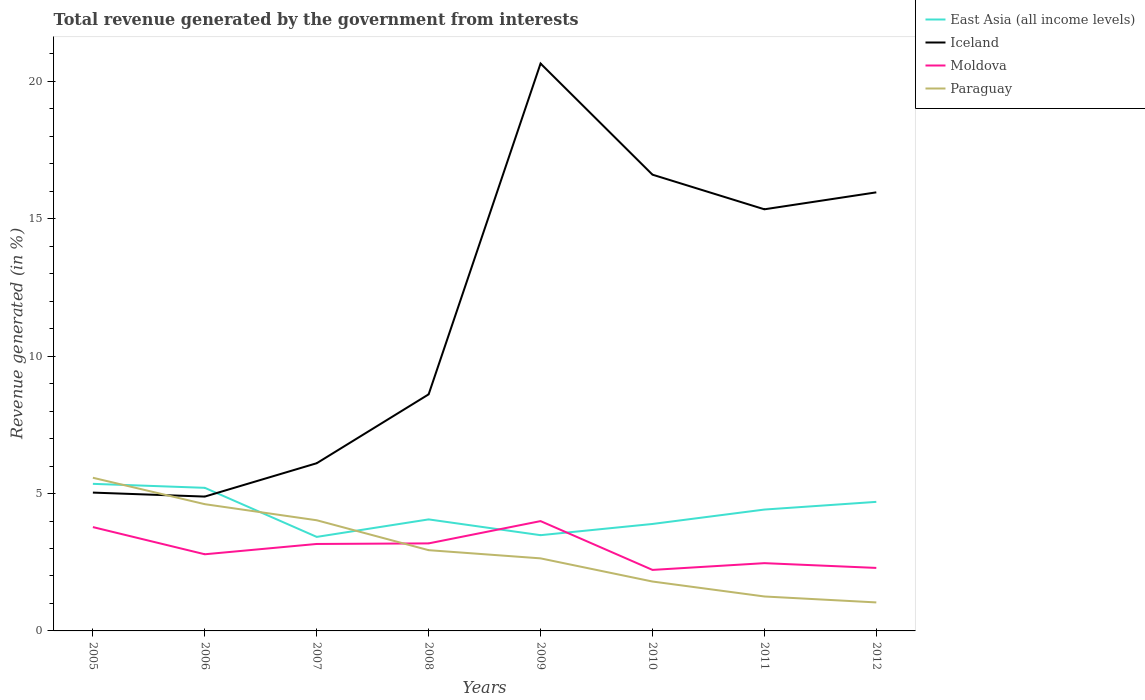How many different coloured lines are there?
Ensure brevity in your answer.  4. Across all years, what is the maximum total revenue generated in Paraguay?
Ensure brevity in your answer.  1.04. What is the total total revenue generated in Iceland in the graph?
Offer a terse response. -1.07. What is the difference between the highest and the second highest total revenue generated in East Asia (all income levels)?
Provide a short and direct response. 1.93. What is the difference between the highest and the lowest total revenue generated in Paraguay?
Give a very brief answer. 3. Is the total revenue generated in East Asia (all income levels) strictly greater than the total revenue generated in Iceland over the years?
Give a very brief answer. No. How many years are there in the graph?
Your response must be concise. 8. Are the values on the major ticks of Y-axis written in scientific E-notation?
Keep it short and to the point. No. Where does the legend appear in the graph?
Your answer should be very brief. Top right. How are the legend labels stacked?
Ensure brevity in your answer.  Vertical. What is the title of the graph?
Your answer should be compact. Total revenue generated by the government from interests. Does "Barbados" appear as one of the legend labels in the graph?
Give a very brief answer. No. What is the label or title of the Y-axis?
Offer a terse response. Revenue generated (in %). What is the Revenue generated (in %) in East Asia (all income levels) in 2005?
Offer a terse response. 5.35. What is the Revenue generated (in %) in Iceland in 2005?
Provide a succinct answer. 5.03. What is the Revenue generated (in %) of Moldova in 2005?
Your answer should be compact. 3.78. What is the Revenue generated (in %) in Paraguay in 2005?
Offer a very short reply. 5.57. What is the Revenue generated (in %) of East Asia (all income levels) in 2006?
Your response must be concise. 5.21. What is the Revenue generated (in %) of Iceland in 2006?
Offer a very short reply. 4.89. What is the Revenue generated (in %) in Moldova in 2006?
Make the answer very short. 2.79. What is the Revenue generated (in %) of Paraguay in 2006?
Your answer should be compact. 4.61. What is the Revenue generated (in %) of East Asia (all income levels) in 2007?
Keep it short and to the point. 3.42. What is the Revenue generated (in %) of Iceland in 2007?
Offer a terse response. 6.1. What is the Revenue generated (in %) in Moldova in 2007?
Offer a terse response. 3.17. What is the Revenue generated (in %) in Paraguay in 2007?
Keep it short and to the point. 4.03. What is the Revenue generated (in %) of East Asia (all income levels) in 2008?
Keep it short and to the point. 4.06. What is the Revenue generated (in %) of Iceland in 2008?
Your response must be concise. 8.61. What is the Revenue generated (in %) of Moldova in 2008?
Your answer should be compact. 3.19. What is the Revenue generated (in %) of Paraguay in 2008?
Provide a succinct answer. 2.94. What is the Revenue generated (in %) in East Asia (all income levels) in 2009?
Ensure brevity in your answer.  3.48. What is the Revenue generated (in %) of Iceland in 2009?
Give a very brief answer. 20.65. What is the Revenue generated (in %) in Moldova in 2009?
Your response must be concise. 4. What is the Revenue generated (in %) in Paraguay in 2009?
Provide a succinct answer. 2.64. What is the Revenue generated (in %) of East Asia (all income levels) in 2010?
Your answer should be very brief. 3.89. What is the Revenue generated (in %) of Iceland in 2010?
Offer a very short reply. 16.61. What is the Revenue generated (in %) of Moldova in 2010?
Keep it short and to the point. 2.22. What is the Revenue generated (in %) in Paraguay in 2010?
Ensure brevity in your answer.  1.8. What is the Revenue generated (in %) of East Asia (all income levels) in 2011?
Make the answer very short. 4.42. What is the Revenue generated (in %) in Iceland in 2011?
Ensure brevity in your answer.  15.35. What is the Revenue generated (in %) of Moldova in 2011?
Your answer should be compact. 2.47. What is the Revenue generated (in %) in Paraguay in 2011?
Give a very brief answer. 1.25. What is the Revenue generated (in %) of East Asia (all income levels) in 2012?
Keep it short and to the point. 4.7. What is the Revenue generated (in %) of Iceland in 2012?
Keep it short and to the point. 15.96. What is the Revenue generated (in %) in Moldova in 2012?
Keep it short and to the point. 2.29. What is the Revenue generated (in %) in Paraguay in 2012?
Provide a short and direct response. 1.04. Across all years, what is the maximum Revenue generated (in %) of East Asia (all income levels)?
Make the answer very short. 5.35. Across all years, what is the maximum Revenue generated (in %) in Iceland?
Your answer should be very brief. 20.65. Across all years, what is the maximum Revenue generated (in %) in Moldova?
Keep it short and to the point. 4. Across all years, what is the maximum Revenue generated (in %) in Paraguay?
Provide a succinct answer. 5.57. Across all years, what is the minimum Revenue generated (in %) of East Asia (all income levels)?
Keep it short and to the point. 3.42. Across all years, what is the minimum Revenue generated (in %) of Iceland?
Your response must be concise. 4.89. Across all years, what is the minimum Revenue generated (in %) in Moldova?
Provide a succinct answer. 2.22. Across all years, what is the minimum Revenue generated (in %) of Paraguay?
Your response must be concise. 1.04. What is the total Revenue generated (in %) of East Asia (all income levels) in the graph?
Your answer should be very brief. 34.54. What is the total Revenue generated (in %) of Iceland in the graph?
Offer a terse response. 93.21. What is the total Revenue generated (in %) in Moldova in the graph?
Keep it short and to the point. 23.9. What is the total Revenue generated (in %) of Paraguay in the graph?
Make the answer very short. 23.89. What is the difference between the Revenue generated (in %) in East Asia (all income levels) in 2005 and that in 2006?
Your answer should be very brief. 0.15. What is the difference between the Revenue generated (in %) of Iceland in 2005 and that in 2006?
Offer a terse response. 0.14. What is the difference between the Revenue generated (in %) in Paraguay in 2005 and that in 2006?
Provide a succinct answer. 0.96. What is the difference between the Revenue generated (in %) of East Asia (all income levels) in 2005 and that in 2007?
Provide a short and direct response. 1.93. What is the difference between the Revenue generated (in %) in Iceland in 2005 and that in 2007?
Offer a very short reply. -1.07. What is the difference between the Revenue generated (in %) in Moldova in 2005 and that in 2007?
Your response must be concise. 0.61. What is the difference between the Revenue generated (in %) of Paraguay in 2005 and that in 2007?
Keep it short and to the point. 1.55. What is the difference between the Revenue generated (in %) in East Asia (all income levels) in 2005 and that in 2008?
Your answer should be compact. 1.29. What is the difference between the Revenue generated (in %) in Iceland in 2005 and that in 2008?
Give a very brief answer. -3.58. What is the difference between the Revenue generated (in %) of Moldova in 2005 and that in 2008?
Give a very brief answer. 0.59. What is the difference between the Revenue generated (in %) in Paraguay in 2005 and that in 2008?
Keep it short and to the point. 2.64. What is the difference between the Revenue generated (in %) of East Asia (all income levels) in 2005 and that in 2009?
Make the answer very short. 1.87. What is the difference between the Revenue generated (in %) in Iceland in 2005 and that in 2009?
Provide a short and direct response. -15.62. What is the difference between the Revenue generated (in %) in Moldova in 2005 and that in 2009?
Make the answer very short. -0.22. What is the difference between the Revenue generated (in %) in Paraguay in 2005 and that in 2009?
Offer a terse response. 2.93. What is the difference between the Revenue generated (in %) in East Asia (all income levels) in 2005 and that in 2010?
Ensure brevity in your answer.  1.46. What is the difference between the Revenue generated (in %) of Iceland in 2005 and that in 2010?
Give a very brief answer. -11.57. What is the difference between the Revenue generated (in %) of Moldova in 2005 and that in 2010?
Offer a very short reply. 1.56. What is the difference between the Revenue generated (in %) in Paraguay in 2005 and that in 2010?
Offer a terse response. 3.78. What is the difference between the Revenue generated (in %) of East Asia (all income levels) in 2005 and that in 2011?
Provide a short and direct response. 0.94. What is the difference between the Revenue generated (in %) of Iceland in 2005 and that in 2011?
Ensure brevity in your answer.  -10.31. What is the difference between the Revenue generated (in %) in Moldova in 2005 and that in 2011?
Ensure brevity in your answer.  1.31. What is the difference between the Revenue generated (in %) in Paraguay in 2005 and that in 2011?
Give a very brief answer. 4.32. What is the difference between the Revenue generated (in %) in East Asia (all income levels) in 2005 and that in 2012?
Provide a succinct answer. 0.66. What is the difference between the Revenue generated (in %) of Iceland in 2005 and that in 2012?
Give a very brief answer. -10.93. What is the difference between the Revenue generated (in %) of Moldova in 2005 and that in 2012?
Offer a very short reply. 1.49. What is the difference between the Revenue generated (in %) in Paraguay in 2005 and that in 2012?
Provide a short and direct response. 4.54. What is the difference between the Revenue generated (in %) of East Asia (all income levels) in 2006 and that in 2007?
Your answer should be compact. 1.79. What is the difference between the Revenue generated (in %) of Iceland in 2006 and that in 2007?
Provide a short and direct response. -1.21. What is the difference between the Revenue generated (in %) in Moldova in 2006 and that in 2007?
Provide a short and direct response. -0.38. What is the difference between the Revenue generated (in %) of Paraguay in 2006 and that in 2007?
Ensure brevity in your answer.  0.59. What is the difference between the Revenue generated (in %) in East Asia (all income levels) in 2006 and that in 2008?
Offer a very short reply. 1.15. What is the difference between the Revenue generated (in %) in Iceland in 2006 and that in 2008?
Offer a terse response. -3.72. What is the difference between the Revenue generated (in %) in Moldova in 2006 and that in 2008?
Give a very brief answer. -0.4. What is the difference between the Revenue generated (in %) in Paraguay in 2006 and that in 2008?
Your answer should be compact. 1.67. What is the difference between the Revenue generated (in %) of East Asia (all income levels) in 2006 and that in 2009?
Make the answer very short. 1.72. What is the difference between the Revenue generated (in %) of Iceland in 2006 and that in 2009?
Ensure brevity in your answer.  -15.76. What is the difference between the Revenue generated (in %) in Moldova in 2006 and that in 2009?
Give a very brief answer. -1.21. What is the difference between the Revenue generated (in %) of Paraguay in 2006 and that in 2009?
Your response must be concise. 1.97. What is the difference between the Revenue generated (in %) of East Asia (all income levels) in 2006 and that in 2010?
Provide a short and direct response. 1.32. What is the difference between the Revenue generated (in %) of Iceland in 2006 and that in 2010?
Provide a short and direct response. -11.72. What is the difference between the Revenue generated (in %) of Moldova in 2006 and that in 2010?
Keep it short and to the point. 0.57. What is the difference between the Revenue generated (in %) of Paraguay in 2006 and that in 2010?
Your response must be concise. 2.82. What is the difference between the Revenue generated (in %) of East Asia (all income levels) in 2006 and that in 2011?
Ensure brevity in your answer.  0.79. What is the difference between the Revenue generated (in %) of Iceland in 2006 and that in 2011?
Provide a short and direct response. -10.46. What is the difference between the Revenue generated (in %) in Moldova in 2006 and that in 2011?
Provide a succinct answer. 0.32. What is the difference between the Revenue generated (in %) in Paraguay in 2006 and that in 2011?
Provide a succinct answer. 3.36. What is the difference between the Revenue generated (in %) in East Asia (all income levels) in 2006 and that in 2012?
Offer a terse response. 0.51. What is the difference between the Revenue generated (in %) in Iceland in 2006 and that in 2012?
Give a very brief answer. -11.07. What is the difference between the Revenue generated (in %) in Moldova in 2006 and that in 2012?
Offer a very short reply. 0.5. What is the difference between the Revenue generated (in %) in Paraguay in 2006 and that in 2012?
Offer a very short reply. 3.58. What is the difference between the Revenue generated (in %) of East Asia (all income levels) in 2007 and that in 2008?
Provide a succinct answer. -0.64. What is the difference between the Revenue generated (in %) of Iceland in 2007 and that in 2008?
Offer a terse response. -2.51. What is the difference between the Revenue generated (in %) in Moldova in 2007 and that in 2008?
Provide a short and direct response. -0.02. What is the difference between the Revenue generated (in %) in Paraguay in 2007 and that in 2008?
Offer a very short reply. 1.09. What is the difference between the Revenue generated (in %) of East Asia (all income levels) in 2007 and that in 2009?
Provide a short and direct response. -0.06. What is the difference between the Revenue generated (in %) in Iceland in 2007 and that in 2009?
Your answer should be very brief. -14.55. What is the difference between the Revenue generated (in %) of Moldova in 2007 and that in 2009?
Your response must be concise. -0.83. What is the difference between the Revenue generated (in %) in Paraguay in 2007 and that in 2009?
Offer a terse response. 1.39. What is the difference between the Revenue generated (in %) of East Asia (all income levels) in 2007 and that in 2010?
Offer a very short reply. -0.47. What is the difference between the Revenue generated (in %) of Iceland in 2007 and that in 2010?
Your answer should be very brief. -10.5. What is the difference between the Revenue generated (in %) in Moldova in 2007 and that in 2010?
Keep it short and to the point. 0.94. What is the difference between the Revenue generated (in %) of Paraguay in 2007 and that in 2010?
Give a very brief answer. 2.23. What is the difference between the Revenue generated (in %) in East Asia (all income levels) in 2007 and that in 2011?
Keep it short and to the point. -1. What is the difference between the Revenue generated (in %) in Iceland in 2007 and that in 2011?
Your answer should be very brief. -9.24. What is the difference between the Revenue generated (in %) in Moldova in 2007 and that in 2011?
Your response must be concise. 0.7. What is the difference between the Revenue generated (in %) of Paraguay in 2007 and that in 2011?
Keep it short and to the point. 2.77. What is the difference between the Revenue generated (in %) of East Asia (all income levels) in 2007 and that in 2012?
Your response must be concise. -1.28. What is the difference between the Revenue generated (in %) of Iceland in 2007 and that in 2012?
Make the answer very short. -9.86. What is the difference between the Revenue generated (in %) of Moldova in 2007 and that in 2012?
Your response must be concise. 0.87. What is the difference between the Revenue generated (in %) in Paraguay in 2007 and that in 2012?
Your response must be concise. 2.99. What is the difference between the Revenue generated (in %) in East Asia (all income levels) in 2008 and that in 2009?
Your answer should be compact. 0.57. What is the difference between the Revenue generated (in %) of Iceland in 2008 and that in 2009?
Offer a very short reply. -12.04. What is the difference between the Revenue generated (in %) of Moldova in 2008 and that in 2009?
Provide a short and direct response. -0.81. What is the difference between the Revenue generated (in %) of Paraguay in 2008 and that in 2009?
Make the answer very short. 0.3. What is the difference between the Revenue generated (in %) in East Asia (all income levels) in 2008 and that in 2010?
Offer a terse response. 0.17. What is the difference between the Revenue generated (in %) in Iceland in 2008 and that in 2010?
Ensure brevity in your answer.  -8. What is the difference between the Revenue generated (in %) in Moldova in 2008 and that in 2010?
Offer a terse response. 0.96. What is the difference between the Revenue generated (in %) in Paraguay in 2008 and that in 2010?
Offer a terse response. 1.14. What is the difference between the Revenue generated (in %) of East Asia (all income levels) in 2008 and that in 2011?
Make the answer very short. -0.36. What is the difference between the Revenue generated (in %) in Iceland in 2008 and that in 2011?
Ensure brevity in your answer.  -6.74. What is the difference between the Revenue generated (in %) in Moldova in 2008 and that in 2011?
Offer a very short reply. 0.72. What is the difference between the Revenue generated (in %) in Paraguay in 2008 and that in 2011?
Offer a very short reply. 1.69. What is the difference between the Revenue generated (in %) in East Asia (all income levels) in 2008 and that in 2012?
Offer a terse response. -0.64. What is the difference between the Revenue generated (in %) of Iceland in 2008 and that in 2012?
Make the answer very short. -7.35. What is the difference between the Revenue generated (in %) in Moldova in 2008 and that in 2012?
Offer a very short reply. 0.89. What is the difference between the Revenue generated (in %) of Paraguay in 2008 and that in 2012?
Give a very brief answer. 1.9. What is the difference between the Revenue generated (in %) of East Asia (all income levels) in 2009 and that in 2010?
Your answer should be very brief. -0.41. What is the difference between the Revenue generated (in %) in Iceland in 2009 and that in 2010?
Your response must be concise. 4.05. What is the difference between the Revenue generated (in %) of Moldova in 2009 and that in 2010?
Provide a succinct answer. 1.78. What is the difference between the Revenue generated (in %) in Paraguay in 2009 and that in 2010?
Ensure brevity in your answer.  0.84. What is the difference between the Revenue generated (in %) of East Asia (all income levels) in 2009 and that in 2011?
Give a very brief answer. -0.93. What is the difference between the Revenue generated (in %) in Iceland in 2009 and that in 2011?
Your answer should be compact. 5.31. What is the difference between the Revenue generated (in %) in Moldova in 2009 and that in 2011?
Give a very brief answer. 1.53. What is the difference between the Revenue generated (in %) in Paraguay in 2009 and that in 2011?
Keep it short and to the point. 1.39. What is the difference between the Revenue generated (in %) in East Asia (all income levels) in 2009 and that in 2012?
Your answer should be very brief. -1.21. What is the difference between the Revenue generated (in %) in Iceland in 2009 and that in 2012?
Your response must be concise. 4.69. What is the difference between the Revenue generated (in %) in Moldova in 2009 and that in 2012?
Ensure brevity in your answer.  1.7. What is the difference between the Revenue generated (in %) in Paraguay in 2009 and that in 2012?
Keep it short and to the point. 1.6. What is the difference between the Revenue generated (in %) of East Asia (all income levels) in 2010 and that in 2011?
Provide a succinct answer. -0.52. What is the difference between the Revenue generated (in %) in Iceland in 2010 and that in 2011?
Your response must be concise. 1.26. What is the difference between the Revenue generated (in %) of Moldova in 2010 and that in 2011?
Your response must be concise. -0.25. What is the difference between the Revenue generated (in %) in Paraguay in 2010 and that in 2011?
Offer a very short reply. 0.54. What is the difference between the Revenue generated (in %) in East Asia (all income levels) in 2010 and that in 2012?
Provide a succinct answer. -0.8. What is the difference between the Revenue generated (in %) of Iceland in 2010 and that in 2012?
Give a very brief answer. 0.64. What is the difference between the Revenue generated (in %) of Moldova in 2010 and that in 2012?
Your answer should be compact. -0.07. What is the difference between the Revenue generated (in %) of Paraguay in 2010 and that in 2012?
Offer a very short reply. 0.76. What is the difference between the Revenue generated (in %) of East Asia (all income levels) in 2011 and that in 2012?
Provide a succinct answer. -0.28. What is the difference between the Revenue generated (in %) of Iceland in 2011 and that in 2012?
Your answer should be compact. -0.62. What is the difference between the Revenue generated (in %) of Moldova in 2011 and that in 2012?
Keep it short and to the point. 0.17. What is the difference between the Revenue generated (in %) in Paraguay in 2011 and that in 2012?
Your answer should be compact. 0.22. What is the difference between the Revenue generated (in %) of East Asia (all income levels) in 2005 and the Revenue generated (in %) of Iceland in 2006?
Your answer should be compact. 0.46. What is the difference between the Revenue generated (in %) in East Asia (all income levels) in 2005 and the Revenue generated (in %) in Moldova in 2006?
Offer a terse response. 2.56. What is the difference between the Revenue generated (in %) of East Asia (all income levels) in 2005 and the Revenue generated (in %) of Paraguay in 2006?
Offer a terse response. 0.74. What is the difference between the Revenue generated (in %) in Iceland in 2005 and the Revenue generated (in %) in Moldova in 2006?
Provide a short and direct response. 2.24. What is the difference between the Revenue generated (in %) of Iceland in 2005 and the Revenue generated (in %) of Paraguay in 2006?
Give a very brief answer. 0.42. What is the difference between the Revenue generated (in %) in Moldova in 2005 and the Revenue generated (in %) in Paraguay in 2006?
Make the answer very short. -0.83. What is the difference between the Revenue generated (in %) in East Asia (all income levels) in 2005 and the Revenue generated (in %) in Iceland in 2007?
Your answer should be very brief. -0.75. What is the difference between the Revenue generated (in %) in East Asia (all income levels) in 2005 and the Revenue generated (in %) in Moldova in 2007?
Your answer should be compact. 2.19. What is the difference between the Revenue generated (in %) of East Asia (all income levels) in 2005 and the Revenue generated (in %) of Paraguay in 2007?
Ensure brevity in your answer.  1.33. What is the difference between the Revenue generated (in %) in Iceland in 2005 and the Revenue generated (in %) in Moldova in 2007?
Your answer should be compact. 1.87. What is the difference between the Revenue generated (in %) of Iceland in 2005 and the Revenue generated (in %) of Paraguay in 2007?
Your response must be concise. 1.01. What is the difference between the Revenue generated (in %) in Moldova in 2005 and the Revenue generated (in %) in Paraguay in 2007?
Offer a very short reply. -0.25. What is the difference between the Revenue generated (in %) of East Asia (all income levels) in 2005 and the Revenue generated (in %) of Iceland in 2008?
Your answer should be very brief. -3.26. What is the difference between the Revenue generated (in %) of East Asia (all income levels) in 2005 and the Revenue generated (in %) of Moldova in 2008?
Provide a succinct answer. 2.17. What is the difference between the Revenue generated (in %) of East Asia (all income levels) in 2005 and the Revenue generated (in %) of Paraguay in 2008?
Give a very brief answer. 2.41. What is the difference between the Revenue generated (in %) of Iceland in 2005 and the Revenue generated (in %) of Moldova in 2008?
Your response must be concise. 1.85. What is the difference between the Revenue generated (in %) of Iceland in 2005 and the Revenue generated (in %) of Paraguay in 2008?
Ensure brevity in your answer.  2.1. What is the difference between the Revenue generated (in %) in Moldova in 2005 and the Revenue generated (in %) in Paraguay in 2008?
Provide a short and direct response. 0.84. What is the difference between the Revenue generated (in %) of East Asia (all income levels) in 2005 and the Revenue generated (in %) of Iceland in 2009?
Ensure brevity in your answer.  -15.3. What is the difference between the Revenue generated (in %) of East Asia (all income levels) in 2005 and the Revenue generated (in %) of Moldova in 2009?
Your answer should be compact. 1.36. What is the difference between the Revenue generated (in %) in East Asia (all income levels) in 2005 and the Revenue generated (in %) in Paraguay in 2009?
Keep it short and to the point. 2.71. What is the difference between the Revenue generated (in %) of Iceland in 2005 and the Revenue generated (in %) of Moldova in 2009?
Your answer should be very brief. 1.04. What is the difference between the Revenue generated (in %) of Iceland in 2005 and the Revenue generated (in %) of Paraguay in 2009?
Your answer should be very brief. 2.39. What is the difference between the Revenue generated (in %) in Moldova in 2005 and the Revenue generated (in %) in Paraguay in 2009?
Provide a short and direct response. 1.14. What is the difference between the Revenue generated (in %) in East Asia (all income levels) in 2005 and the Revenue generated (in %) in Iceland in 2010?
Make the answer very short. -11.25. What is the difference between the Revenue generated (in %) of East Asia (all income levels) in 2005 and the Revenue generated (in %) of Moldova in 2010?
Ensure brevity in your answer.  3.13. What is the difference between the Revenue generated (in %) in East Asia (all income levels) in 2005 and the Revenue generated (in %) in Paraguay in 2010?
Provide a succinct answer. 3.56. What is the difference between the Revenue generated (in %) of Iceland in 2005 and the Revenue generated (in %) of Moldova in 2010?
Keep it short and to the point. 2.81. What is the difference between the Revenue generated (in %) in Iceland in 2005 and the Revenue generated (in %) in Paraguay in 2010?
Offer a terse response. 3.24. What is the difference between the Revenue generated (in %) in Moldova in 2005 and the Revenue generated (in %) in Paraguay in 2010?
Provide a succinct answer. 1.98. What is the difference between the Revenue generated (in %) of East Asia (all income levels) in 2005 and the Revenue generated (in %) of Iceland in 2011?
Provide a short and direct response. -9.99. What is the difference between the Revenue generated (in %) in East Asia (all income levels) in 2005 and the Revenue generated (in %) in Moldova in 2011?
Ensure brevity in your answer.  2.89. What is the difference between the Revenue generated (in %) in East Asia (all income levels) in 2005 and the Revenue generated (in %) in Paraguay in 2011?
Offer a very short reply. 4.1. What is the difference between the Revenue generated (in %) in Iceland in 2005 and the Revenue generated (in %) in Moldova in 2011?
Your answer should be compact. 2.57. What is the difference between the Revenue generated (in %) in Iceland in 2005 and the Revenue generated (in %) in Paraguay in 2011?
Ensure brevity in your answer.  3.78. What is the difference between the Revenue generated (in %) of Moldova in 2005 and the Revenue generated (in %) of Paraguay in 2011?
Offer a very short reply. 2.53. What is the difference between the Revenue generated (in %) of East Asia (all income levels) in 2005 and the Revenue generated (in %) of Iceland in 2012?
Offer a very short reply. -10.61. What is the difference between the Revenue generated (in %) in East Asia (all income levels) in 2005 and the Revenue generated (in %) in Moldova in 2012?
Your answer should be compact. 3.06. What is the difference between the Revenue generated (in %) of East Asia (all income levels) in 2005 and the Revenue generated (in %) of Paraguay in 2012?
Your answer should be very brief. 4.32. What is the difference between the Revenue generated (in %) in Iceland in 2005 and the Revenue generated (in %) in Moldova in 2012?
Your answer should be compact. 2.74. What is the difference between the Revenue generated (in %) of Iceland in 2005 and the Revenue generated (in %) of Paraguay in 2012?
Ensure brevity in your answer.  4. What is the difference between the Revenue generated (in %) of Moldova in 2005 and the Revenue generated (in %) of Paraguay in 2012?
Provide a succinct answer. 2.74. What is the difference between the Revenue generated (in %) in East Asia (all income levels) in 2006 and the Revenue generated (in %) in Iceland in 2007?
Ensure brevity in your answer.  -0.9. What is the difference between the Revenue generated (in %) in East Asia (all income levels) in 2006 and the Revenue generated (in %) in Moldova in 2007?
Offer a very short reply. 2.04. What is the difference between the Revenue generated (in %) of East Asia (all income levels) in 2006 and the Revenue generated (in %) of Paraguay in 2007?
Your response must be concise. 1.18. What is the difference between the Revenue generated (in %) of Iceland in 2006 and the Revenue generated (in %) of Moldova in 2007?
Give a very brief answer. 1.72. What is the difference between the Revenue generated (in %) of Iceland in 2006 and the Revenue generated (in %) of Paraguay in 2007?
Provide a short and direct response. 0.86. What is the difference between the Revenue generated (in %) in Moldova in 2006 and the Revenue generated (in %) in Paraguay in 2007?
Offer a very short reply. -1.24. What is the difference between the Revenue generated (in %) in East Asia (all income levels) in 2006 and the Revenue generated (in %) in Iceland in 2008?
Ensure brevity in your answer.  -3.4. What is the difference between the Revenue generated (in %) in East Asia (all income levels) in 2006 and the Revenue generated (in %) in Moldova in 2008?
Your response must be concise. 2.02. What is the difference between the Revenue generated (in %) in East Asia (all income levels) in 2006 and the Revenue generated (in %) in Paraguay in 2008?
Your answer should be very brief. 2.27. What is the difference between the Revenue generated (in %) of Iceland in 2006 and the Revenue generated (in %) of Moldova in 2008?
Your answer should be compact. 1.7. What is the difference between the Revenue generated (in %) in Iceland in 2006 and the Revenue generated (in %) in Paraguay in 2008?
Your response must be concise. 1.95. What is the difference between the Revenue generated (in %) of Moldova in 2006 and the Revenue generated (in %) of Paraguay in 2008?
Ensure brevity in your answer.  -0.15. What is the difference between the Revenue generated (in %) of East Asia (all income levels) in 2006 and the Revenue generated (in %) of Iceland in 2009?
Provide a succinct answer. -15.44. What is the difference between the Revenue generated (in %) in East Asia (all income levels) in 2006 and the Revenue generated (in %) in Moldova in 2009?
Provide a succinct answer. 1.21. What is the difference between the Revenue generated (in %) in East Asia (all income levels) in 2006 and the Revenue generated (in %) in Paraguay in 2009?
Offer a terse response. 2.57. What is the difference between the Revenue generated (in %) in Iceland in 2006 and the Revenue generated (in %) in Moldova in 2009?
Give a very brief answer. 0.89. What is the difference between the Revenue generated (in %) in Iceland in 2006 and the Revenue generated (in %) in Paraguay in 2009?
Your answer should be compact. 2.25. What is the difference between the Revenue generated (in %) of Moldova in 2006 and the Revenue generated (in %) of Paraguay in 2009?
Your answer should be very brief. 0.15. What is the difference between the Revenue generated (in %) in East Asia (all income levels) in 2006 and the Revenue generated (in %) in Iceland in 2010?
Your answer should be compact. -11.4. What is the difference between the Revenue generated (in %) in East Asia (all income levels) in 2006 and the Revenue generated (in %) in Moldova in 2010?
Make the answer very short. 2.99. What is the difference between the Revenue generated (in %) of East Asia (all income levels) in 2006 and the Revenue generated (in %) of Paraguay in 2010?
Provide a succinct answer. 3.41. What is the difference between the Revenue generated (in %) in Iceland in 2006 and the Revenue generated (in %) in Moldova in 2010?
Give a very brief answer. 2.67. What is the difference between the Revenue generated (in %) of Iceland in 2006 and the Revenue generated (in %) of Paraguay in 2010?
Keep it short and to the point. 3.09. What is the difference between the Revenue generated (in %) of East Asia (all income levels) in 2006 and the Revenue generated (in %) of Iceland in 2011?
Provide a succinct answer. -10.14. What is the difference between the Revenue generated (in %) in East Asia (all income levels) in 2006 and the Revenue generated (in %) in Moldova in 2011?
Provide a short and direct response. 2.74. What is the difference between the Revenue generated (in %) in East Asia (all income levels) in 2006 and the Revenue generated (in %) in Paraguay in 2011?
Offer a terse response. 3.96. What is the difference between the Revenue generated (in %) of Iceland in 2006 and the Revenue generated (in %) of Moldova in 2011?
Your answer should be very brief. 2.42. What is the difference between the Revenue generated (in %) of Iceland in 2006 and the Revenue generated (in %) of Paraguay in 2011?
Offer a terse response. 3.64. What is the difference between the Revenue generated (in %) in Moldova in 2006 and the Revenue generated (in %) in Paraguay in 2011?
Ensure brevity in your answer.  1.54. What is the difference between the Revenue generated (in %) in East Asia (all income levels) in 2006 and the Revenue generated (in %) in Iceland in 2012?
Offer a very short reply. -10.76. What is the difference between the Revenue generated (in %) of East Asia (all income levels) in 2006 and the Revenue generated (in %) of Moldova in 2012?
Give a very brief answer. 2.92. What is the difference between the Revenue generated (in %) in East Asia (all income levels) in 2006 and the Revenue generated (in %) in Paraguay in 2012?
Provide a short and direct response. 4.17. What is the difference between the Revenue generated (in %) of Iceland in 2006 and the Revenue generated (in %) of Moldova in 2012?
Keep it short and to the point. 2.6. What is the difference between the Revenue generated (in %) in Iceland in 2006 and the Revenue generated (in %) in Paraguay in 2012?
Ensure brevity in your answer.  3.85. What is the difference between the Revenue generated (in %) of Moldova in 2006 and the Revenue generated (in %) of Paraguay in 2012?
Give a very brief answer. 1.75. What is the difference between the Revenue generated (in %) of East Asia (all income levels) in 2007 and the Revenue generated (in %) of Iceland in 2008?
Ensure brevity in your answer.  -5.19. What is the difference between the Revenue generated (in %) in East Asia (all income levels) in 2007 and the Revenue generated (in %) in Moldova in 2008?
Ensure brevity in your answer.  0.24. What is the difference between the Revenue generated (in %) in East Asia (all income levels) in 2007 and the Revenue generated (in %) in Paraguay in 2008?
Provide a short and direct response. 0.48. What is the difference between the Revenue generated (in %) of Iceland in 2007 and the Revenue generated (in %) of Moldova in 2008?
Provide a short and direct response. 2.92. What is the difference between the Revenue generated (in %) of Iceland in 2007 and the Revenue generated (in %) of Paraguay in 2008?
Provide a short and direct response. 3.17. What is the difference between the Revenue generated (in %) in Moldova in 2007 and the Revenue generated (in %) in Paraguay in 2008?
Make the answer very short. 0.23. What is the difference between the Revenue generated (in %) of East Asia (all income levels) in 2007 and the Revenue generated (in %) of Iceland in 2009?
Your response must be concise. -17.23. What is the difference between the Revenue generated (in %) of East Asia (all income levels) in 2007 and the Revenue generated (in %) of Moldova in 2009?
Your response must be concise. -0.57. What is the difference between the Revenue generated (in %) in East Asia (all income levels) in 2007 and the Revenue generated (in %) in Paraguay in 2009?
Provide a short and direct response. 0.78. What is the difference between the Revenue generated (in %) of Iceland in 2007 and the Revenue generated (in %) of Moldova in 2009?
Provide a short and direct response. 2.11. What is the difference between the Revenue generated (in %) of Iceland in 2007 and the Revenue generated (in %) of Paraguay in 2009?
Your answer should be very brief. 3.46. What is the difference between the Revenue generated (in %) in Moldova in 2007 and the Revenue generated (in %) in Paraguay in 2009?
Your answer should be very brief. 0.52. What is the difference between the Revenue generated (in %) of East Asia (all income levels) in 2007 and the Revenue generated (in %) of Iceland in 2010?
Offer a very short reply. -13.18. What is the difference between the Revenue generated (in %) in East Asia (all income levels) in 2007 and the Revenue generated (in %) in Moldova in 2010?
Your answer should be very brief. 1.2. What is the difference between the Revenue generated (in %) of East Asia (all income levels) in 2007 and the Revenue generated (in %) of Paraguay in 2010?
Keep it short and to the point. 1.62. What is the difference between the Revenue generated (in %) of Iceland in 2007 and the Revenue generated (in %) of Moldova in 2010?
Offer a very short reply. 3.88. What is the difference between the Revenue generated (in %) of Iceland in 2007 and the Revenue generated (in %) of Paraguay in 2010?
Provide a short and direct response. 4.31. What is the difference between the Revenue generated (in %) of Moldova in 2007 and the Revenue generated (in %) of Paraguay in 2010?
Offer a very short reply. 1.37. What is the difference between the Revenue generated (in %) in East Asia (all income levels) in 2007 and the Revenue generated (in %) in Iceland in 2011?
Keep it short and to the point. -11.92. What is the difference between the Revenue generated (in %) of East Asia (all income levels) in 2007 and the Revenue generated (in %) of Moldova in 2011?
Offer a very short reply. 0.96. What is the difference between the Revenue generated (in %) of East Asia (all income levels) in 2007 and the Revenue generated (in %) of Paraguay in 2011?
Your response must be concise. 2.17. What is the difference between the Revenue generated (in %) in Iceland in 2007 and the Revenue generated (in %) in Moldova in 2011?
Offer a very short reply. 3.64. What is the difference between the Revenue generated (in %) of Iceland in 2007 and the Revenue generated (in %) of Paraguay in 2011?
Your answer should be compact. 4.85. What is the difference between the Revenue generated (in %) of Moldova in 2007 and the Revenue generated (in %) of Paraguay in 2011?
Ensure brevity in your answer.  1.91. What is the difference between the Revenue generated (in %) of East Asia (all income levels) in 2007 and the Revenue generated (in %) of Iceland in 2012?
Provide a succinct answer. -12.54. What is the difference between the Revenue generated (in %) of East Asia (all income levels) in 2007 and the Revenue generated (in %) of Moldova in 2012?
Give a very brief answer. 1.13. What is the difference between the Revenue generated (in %) in East Asia (all income levels) in 2007 and the Revenue generated (in %) in Paraguay in 2012?
Offer a terse response. 2.39. What is the difference between the Revenue generated (in %) in Iceland in 2007 and the Revenue generated (in %) in Moldova in 2012?
Ensure brevity in your answer.  3.81. What is the difference between the Revenue generated (in %) of Iceland in 2007 and the Revenue generated (in %) of Paraguay in 2012?
Offer a terse response. 5.07. What is the difference between the Revenue generated (in %) in Moldova in 2007 and the Revenue generated (in %) in Paraguay in 2012?
Provide a short and direct response. 2.13. What is the difference between the Revenue generated (in %) of East Asia (all income levels) in 2008 and the Revenue generated (in %) of Iceland in 2009?
Provide a short and direct response. -16.59. What is the difference between the Revenue generated (in %) in East Asia (all income levels) in 2008 and the Revenue generated (in %) in Moldova in 2009?
Provide a short and direct response. 0.06. What is the difference between the Revenue generated (in %) in East Asia (all income levels) in 2008 and the Revenue generated (in %) in Paraguay in 2009?
Offer a very short reply. 1.42. What is the difference between the Revenue generated (in %) of Iceland in 2008 and the Revenue generated (in %) of Moldova in 2009?
Your response must be concise. 4.61. What is the difference between the Revenue generated (in %) of Iceland in 2008 and the Revenue generated (in %) of Paraguay in 2009?
Your answer should be very brief. 5.97. What is the difference between the Revenue generated (in %) in Moldova in 2008 and the Revenue generated (in %) in Paraguay in 2009?
Your answer should be compact. 0.55. What is the difference between the Revenue generated (in %) of East Asia (all income levels) in 2008 and the Revenue generated (in %) of Iceland in 2010?
Offer a very short reply. -12.55. What is the difference between the Revenue generated (in %) in East Asia (all income levels) in 2008 and the Revenue generated (in %) in Moldova in 2010?
Your response must be concise. 1.84. What is the difference between the Revenue generated (in %) of East Asia (all income levels) in 2008 and the Revenue generated (in %) of Paraguay in 2010?
Your answer should be compact. 2.26. What is the difference between the Revenue generated (in %) in Iceland in 2008 and the Revenue generated (in %) in Moldova in 2010?
Provide a short and direct response. 6.39. What is the difference between the Revenue generated (in %) of Iceland in 2008 and the Revenue generated (in %) of Paraguay in 2010?
Offer a terse response. 6.81. What is the difference between the Revenue generated (in %) of Moldova in 2008 and the Revenue generated (in %) of Paraguay in 2010?
Keep it short and to the point. 1.39. What is the difference between the Revenue generated (in %) of East Asia (all income levels) in 2008 and the Revenue generated (in %) of Iceland in 2011?
Offer a terse response. -11.29. What is the difference between the Revenue generated (in %) of East Asia (all income levels) in 2008 and the Revenue generated (in %) of Moldova in 2011?
Provide a succinct answer. 1.59. What is the difference between the Revenue generated (in %) in East Asia (all income levels) in 2008 and the Revenue generated (in %) in Paraguay in 2011?
Ensure brevity in your answer.  2.81. What is the difference between the Revenue generated (in %) in Iceland in 2008 and the Revenue generated (in %) in Moldova in 2011?
Offer a terse response. 6.14. What is the difference between the Revenue generated (in %) of Iceland in 2008 and the Revenue generated (in %) of Paraguay in 2011?
Your answer should be compact. 7.36. What is the difference between the Revenue generated (in %) in Moldova in 2008 and the Revenue generated (in %) in Paraguay in 2011?
Give a very brief answer. 1.93. What is the difference between the Revenue generated (in %) of East Asia (all income levels) in 2008 and the Revenue generated (in %) of Iceland in 2012?
Your answer should be very brief. -11.9. What is the difference between the Revenue generated (in %) in East Asia (all income levels) in 2008 and the Revenue generated (in %) in Moldova in 2012?
Provide a short and direct response. 1.77. What is the difference between the Revenue generated (in %) of East Asia (all income levels) in 2008 and the Revenue generated (in %) of Paraguay in 2012?
Ensure brevity in your answer.  3.02. What is the difference between the Revenue generated (in %) in Iceland in 2008 and the Revenue generated (in %) in Moldova in 2012?
Provide a short and direct response. 6.32. What is the difference between the Revenue generated (in %) in Iceland in 2008 and the Revenue generated (in %) in Paraguay in 2012?
Ensure brevity in your answer.  7.57. What is the difference between the Revenue generated (in %) of Moldova in 2008 and the Revenue generated (in %) of Paraguay in 2012?
Keep it short and to the point. 2.15. What is the difference between the Revenue generated (in %) of East Asia (all income levels) in 2009 and the Revenue generated (in %) of Iceland in 2010?
Offer a very short reply. -13.12. What is the difference between the Revenue generated (in %) of East Asia (all income levels) in 2009 and the Revenue generated (in %) of Moldova in 2010?
Provide a succinct answer. 1.26. What is the difference between the Revenue generated (in %) in East Asia (all income levels) in 2009 and the Revenue generated (in %) in Paraguay in 2010?
Provide a succinct answer. 1.69. What is the difference between the Revenue generated (in %) in Iceland in 2009 and the Revenue generated (in %) in Moldova in 2010?
Keep it short and to the point. 18.43. What is the difference between the Revenue generated (in %) of Iceland in 2009 and the Revenue generated (in %) of Paraguay in 2010?
Your answer should be compact. 18.86. What is the difference between the Revenue generated (in %) of Moldova in 2009 and the Revenue generated (in %) of Paraguay in 2010?
Offer a very short reply. 2.2. What is the difference between the Revenue generated (in %) in East Asia (all income levels) in 2009 and the Revenue generated (in %) in Iceland in 2011?
Offer a very short reply. -11.86. What is the difference between the Revenue generated (in %) in East Asia (all income levels) in 2009 and the Revenue generated (in %) in Moldova in 2011?
Keep it short and to the point. 1.02. What is the difference between the Revenue generated (in %) in East Asia (all income levels) in 2009 and the Revenue generated (in %) in Paraguay in 2011?
Your answer should be compact. 2.23. What is the difference between the Revenue generated (in %) in Iceland in 2009 and the Revenue generated (in %) in Moldova in 2011?
Provide a short and direct response. 18.19. What is the difference between the Revenue generated (in %) of Iceland in 2009 and the Revenue generated (in %) of Paraguay in 2011?
Ensure brevity in your answer.  19.4. What is the difference between the Revenue generated (in %) in Moldova in 2009 and the Revenue generated (in %) in Paraguay in 2011?
Your answer should be very brief. 2.74. What is the difference between the Revenue generated (in %) in East Asia (all income levels) in 2009 and the Revenue generated (in %) in Iceland in 2012?
Give a very brief answer. -12.48. What is the difference between the Revenue generated (in %) of East Asia (all income levels) in 2009 and the Revenue generated (in %) of Moldova in 2012?
Ensure brevity in your answer.  1.19. What is the difference between the Revenue generated (in %) in East Asia (all income levels) in 2009 and the Revenue generated (in %) in Paraguay in 2012?
Offer a terse response. 2.45. What is the difference between the Revenue generated (in %) of Iceland in 2009 and the Revenue generated (in %) of Moldova in 2012?
Keep it short and to the point. 18.36. What is the difference between the Revenue generated (in %) in Iceland in 2009 and the Revenue generated (in %) in Paraguay in 2012?
Make the answer very short. 19.62. What is the difference between the Revenue generated (in %) of Moldova in 2009 and the Revenue generated (in %) of Paraguay in 2012?
Offer a terse response. 2.96. What is the difference between the Revenue generated (in %) of East Asia (all income levels) in 2010 and the Revenue generated (in %) of Iceland in 2011?
Make the answer very short. -11.45. What is the difference between the Revenue generated (in %) of East Asia (all income levels) in 2010 and the Revenue generated (in %) of Moldova in 2011?
Provide a short and direct response. 1.43. What is the difference between the Revenue generated (in %) in East Asia (all income levels) in 2010 and the Revenue generated (in %) in Paraguay in 2011?
Offer a terse response. 2.64. What is the difference between the Revenue generated (in %) in Iceland in 2010 and the Revenue generated (in %) in Moldova in 2011?
Your response must be concise. 14.14. What is the difference between the Revenue generated (in %) of Iceland in 2010 and the Revenue generated (in %) of Paraguay in 2011?
Your answer should be compact. 15.35. What is the difference between the Revenue generated (in %) of Moldova in 2010 and the Revenue generated (in %) of Paraguay in 2011?
Offer a terse response. 0.97. What is the difference between the Revenue generated (in %) in East Asia (all income levels) in 2010 and the Revenue generated (in %) in Iceland in 2012?
Give a very brief answer. -12.07. What is the difference between the Revenue generated (in %) in East Asia (all income levels) in 2010 and the Revenue generated (in %) in Moldova in 2012?
Ensure brevity in your answer.  1.6. What is the difference between the Revenue generated (in %) of East Asia (all income levels) in 2010 and the Revenue generated (in %) of Paraguay in 2012?
Offer a very short reply. 2.86. What is the difference between the Revenue generated (in %) of Iceland in 2010 and the Revenue generated (in %) of Moldova in 2012?
Your response must be concise. 14.31. What is the difference between the Revenue generated (in %) of Iceland in 2010 and the Revenue generated (in %) of Paraguay in 2012?
Give a very brief answer. 15.57. What is the difference between the Revenue generated (in %) in Moldova in 2010 and the Revenue generated (in %) in Paraguay in 2012?
Offer a very short reply. 1.18. What is the difference between the Revenue generated (in %) in East Asia (all income levels) in 2011 and the Revenue generated (in %) in Iceland in 2012?
Provide a short and direct response. -11.55. What is the difference between the Revenue generated (in %) of East Asia (all income levels) in 2011 and the Revenue generated (in %) of Moldova in 2012?
Offer a very short reply. 2.12. What is the difference between the Revenue generated (in %) in East Asia (all income levels) in 2011 and the Revenue generated (in %) in Paraguay in 2012?
Offer a very short reply. 3.38. What is the difference between the Revenue generated (in %) in Iceland in 2011 and the Revenue generated (in %) in Moldova in 2012?
Make the answer very short. 13.05. What is the difference between the Revenue generated (in %) in Iceland in 2011 and the Revenue generated (in %) in Paraguay in 2012?
Your answer should be compact. 14.31. What is the difference between the Revenue generated (in %) of Moldova in 2011 and the Revenue generated (in %) of Paraguay in 2012?
Provide a short and direct response. 1.43. What is the average Revenue generated (in %) of East Asia (all income levels) per year?
Provide a short and direct response. 4.32. What is the average Revenue generated (in %) of Iceland per year?
Your answer should be very brief. 11.65. What is the average Revenue generated (in %) of Moldova per year?
Ensure brevity in your answer.  2.99. What is the average Revenue generated (in %) in Paraguay per year?
Offer a terse response. 2.99. In the year 2005, what is the difference between the Revenue generated (in %) of East Asia (all income levels) and Revenue generated (in %) of Iceland?
Give a very brief answer. 0.32. In the year 2005, what is the difference between the Revenue generated (in %) of East Asia (all income levels) and Revenue generated (in %) of Moldova?
Provide a succinct answer. 1.57. In the year 2005, what is the difference between the Revenue generated (in %) in East Asia (all income levels) and Revenue generated (in %) in Paraguay?
Make the answer very short. -0.22. In the year 2005, what is the difference between the Revenue generated (in %) in Iceland and Revenue generated (in %) in Moldova?
Give a very brief answer. 1.26. In the year 2005, what is the difference between the Revenue generated (in %) in Iceland and Revenue generated (in %) in Paraguay?
Your answer should be compact. -0.54. In the year 2005, what is the difference between the Revenue generated (in %) in Moldova and Revenue generated (in %) in Paraguay?
Provide a succinct answer. -1.8. In the year 2006, what is the difference between the Revenue generated (in %) of East Asia (all income levels) and Revenue generated (in %) of Iceland?
Your answer should be very brief. 0.32. In the year 2006, what is the difference between the Revenue generated (in %) of East Asia (all income levels) and Revenue generated (in %) of Moldova?
Your answer should be compact. 2.42. In the year 2006, what is the difference between the Revenue generated (in %) in East Asia (all income levels) and Revenue generated (in %) in Paraguay?
Ensure brevity in your answer.  0.6. In the year 2006, what is the difference between the Revenue generated (in %) in Iceland and Revenue generated (in %) in Moldova?
Make the answer very short. 2.1. In the year 2006, what is the difference between the Revenue generated (in %) in Iceland and Revenue generated (in %) in Paraguay?
Offer a very short reply. 0.28. In the year 2006, what is the difference between the Revenue generated (in %) in Moldova and Revenue generated (in %) in Paraguay?
Your answer should be compact. -1.82. In the year 2007, what is the difference between the Revenue generated (in %) in East Asia (all income levels) and Revenue generated (in %) in Iceland?
Provide a succinct answer. -2.68. In the year 2007, what is the difference between the Revenue generated (in %) of East Asia (all income levels) and Revenue generated (in %) of Moldova?
Provide a succinct answer. 0.26. In the year 2007, what is the difference between the Revenue generated (in %) in East Asia (all income levels) and Revenue generated (in %) in Paraguay?
Offer a terse response. -0.61. In the year 2007, what is the difference between the Revenue generated (in %) of Iceland and Revenue generated (in %) of Moldova?
Give a very brief answer. 2.94. In the year 2007, what is the difference between the Revenue generated (in %) of Iceland and Revenue generated (in %) of Paraguay?
Keep it short and to the point. 2.08. In the year 2007, what is the difference between the Revenue generated (in %) in Moldova and Revenue generated (in %) in Paraguay?
Your response must be concise. -0.86. In the year 2008, what is the difference between the Revenue generated (in %) in East Asia (all income levels) and Revenue generated (in %) in Iceland?
Keep it short and to the point. -4.55. In the year 2008, what is the difference between the Revenue generated (in %) of East Asia (all income levels) and Revenue generated (in %) of Moldova?
Give a very brief answer. 0.87. In the year 2008, what is the difference between the Revenue generated (in %) in East Asia (all income levels) and Revenue generated (in %) in Paraguay?
Your answer should be very brief. 1.12. In the year 2008, what is the difference between the Revenue generated (in %) in Iceland and Revenue generated (in %) in Moldova?
Provide a succinct answer. 5.42. In the year 2008, what is the difference between the Revenue generated (in %) of Iceland and Revenue generated (in %) of Paraguay?
Make the answer very short. 5.67. In the year 2008, what is the difference between the Revenue generated (in %) of Moldova and Revenue generated (in %) of Paraguay?
Give a very brief answer. 0.25. In the year 2009, what is the difference between the Revenue generated (in %) in East Asia (all income levels) and Revenue generated (in %) in Iceland?
Your answer should be compact. -17.17. In the year 2009, what is the difference between the Revenue generated (in %) of East Asia (all income levels) and Revenue generated (in %) of Moldova?
Offer a very short reply. -0.51. In the year 2009, what is the difference between the Revenue generated (in %) of East Asia (all income levels) and Revenue generated (in %) of Paraguay?
Ensure brevity in your answer.  0.84. In the year 2009, what is the difference between the Revenue generated (in %) of Iceland and Revenue generated (in %) of Moldova?
Offer a very short reply. 16.66. In the year 2009, what is the difference between the Revenue generated (in %) in Iceland and Revenue generated (in %) in Paraguay?
Provide a succinct answer. 18.01. In the year 2009, what is the difference between the Revenue generated (in %) in Moldova and Revenue generated (in %) in Paraguay?
Give a very brief answer. 1.36. In the year 2010, what is the difference between the Revenue generated (in %) in East Asia (all income levels) and Revenue generated (in %) in Iceland?
Provide a short and direct response. -12.71. In the year 2010, what is the difference between the Revenue generated (in %) of East Asia (all income levels) and Revenue generated (in %) of Moldova?
Provide a succinct answer. 1.67. In the year 2010, what is the difference between the Revenue generated (in %) of East Asia (all income levels) and Revenue generated (in %) of Paraguay?
Your answer should be compact. 2.1. In the year 2010, what is the difference between the Revenue generated (in %) of Iceland and Revenue generated (in %) of Moldova?
Provide a succinct answer. 14.39. In the year 2010, what is the difference between the Revenue generated (in %) of Iceland and Revenue generated (in %) of Paraguay?
Your response must be concise. 14.81. In the year 2010, what is the difference between the Revenue generated (in %) in Moldova and Revenue generated (in %) in Paraguay?
Offer a very short reply. 0.42. In the year 2011, what is the difference between the Revenue generated (in %) of East Asia (all income levels) and Revenue generated (in %) of Iceland?
Your response must be concise. -10.93. In the year 2011, what is the difference between the Revenue generated (in %) of East Asia (all income levels) and Revenue generated (in %) of Moldova?
Provide a succinct answer. 1.95. In the year 2011, what is the difference between the Revenue generated (in %) of East Asia (all income levels) and Revenue generated (in %) of Paraguay?
Provide a short and direct response. 3.16. In the year 2011, what is the difference between the Revenue generated (in %) in Iceland and Revenue generated (in %) in Moldova?
Provide a short and direct response. 12.88. In the year 2011, what is the difference between the Revenue generated (in %) of Iceland and Revenue generated (in %) of Paraguay?
Your answer should be compact. 14.09. In the year 2011, what is the difference between the Revenue generated (in %) in Moldova and Revenue generated (in %) in Paraguay?
Offer a very short reply. 1.21. In the year 2012, what is the difference between the Revenue generated (in %) in East Asia (all income levels) and Revenue generated (in %) in Iceland?
Your response must be concise. -11.27. In the year 2012, what is the difference between the Revenue generated (in %) of East Asia (all income levels) and Revenue generated (in %) of Moldova?
Your answer should be very brief. 2.4. In the year 2012, what is the difference between the Revenue generated (in %) in East Asia (all income levels) and Revenue generated (in %) in Paraguay?
Offer a very short reply. 3.66. In the year 2012, what is the difference between the Revenue generated (in %) in Iceland and Revenue generated (in %) in Moldova?
Ensure brevity in your answer.  13.67. In the year 2012, what is the difference between the Revenue generated (in %) in Iceland and Revenue generated (in %) in Paraguay?
Your answer should be compact. 14.93. In the year 2012, what is the difference between the Revenue generated (in %) of Moldova and Revenue generated (in %) of Paraguay?
Offer a very short reply. 1.26. What is the ratio of the Revenue generated (in %) of East Asia (all income levels) in 2005 to that in 2006?
Your answer should be very brief. 1.03. What is the ratio of the Revenue generated (in %) in Iceland in 2005 to that in 2006?
Provide a succinct answer. 1.03. What is the ratio of the Revenue generated (in %) in Moldova in 2005 to that in 2006?
Give a very brief answer. 1.35. What is the ratio of the Revenue generated (in %) of Paraguay in 2005 to that in 2006?
Give a very brief answer. 1.21. What is the ratio of the Revenue generated (in %) in East Asia (all income levels) in 2005 to that in 2007?
Keep it short and to the point. 1.56. What is the ratio of the Revenue generated (in %) in Iceland in 2005 to that in 2007?
Provide a short and direct response. 0.82. What is the ratio of the Revenue generated (in %) in Moldova in 2005 to that in 2007?
Offer a terse response. 1.19. What is the ratio of the Revenue generated (in %) in Paraguay in 2005 to that in 2007?
Your answer should be very brief. 1.38. What is the ratio of the Revenue generated (in %) in East Asia (all income levels) in 2005 to that in 2008?
Ensure brevity in your answer.  1.32. What is the ratio of the Revenue generated (in %) in Iceland in 2005 to that in 2008?
Give a very brief answer. 0.58. What is the ratio of the Revenue generated (in %) in Moldova in 2005 to that in 2008?
Provide a short and direct response. 1.19. What is the ratio of the Revenue generated (in %) in Paraguay in 2005 to that in 2008?
Keep it short and to the point. 1.9. What is the ratio of the Revenue generated (in %) in East Asia (all income levels) in 2005 to that in 2009?
Give a very brief answer. 1.54. What is the ratio of the Revenue generated (in %) in Iceland in 2005 to that in 2009?
Make the answer very short. 0.24. What is the ratio of the Revenue generated (in %) of Moldova in 2005 to that in 2009?
Make the answer very short. 0.95. What is the ratio of the Revenue generated (in %) in Paraguay in 2005 to that in 2009?
Your answer should be very brief. 2.11. What is the ratio of the Revenue generated (in %) in East Asia (all income levels) in 2005 to that in 2010?
Your response must be concise. 1.38. What is the ratio of the Revenue generated (in %) of Iceland in 2005 to that in 2010?
Your answer should be compact. 0.3. What is the ratio of the Revenue generated (in %) in Moldova in 2005 to that in 2010?
Your answer should be compact. 1.7. What is the ratio of the Revenue generated (in %) in Paraguay in 2005 to that in 2010?
Keep it short and to the point. 3.1. What is the ratio of the Revenue generated (in %) in East Asia (all income levels) in 2005 to that in 2011?
Your answer should be very brief. 1.21. What is the ratio of the Revenue generated (in %) in Iceland in 2005 to that in 2011?
Keep it short and to the point. 0.33. What is the ratio of the Revenue generated (in %) in Moldova in 2005 to that in 2011?
Your answer should be very brief. 1.53. What is the ratio of the Revenue generated (in %) of Paraguay in 2005 to that in 2011?
Your response must be concise. 4.45. What is the ratio of the Revenue generated (in %) in East Asia (all income levels) in 2005 to that in 2012?
Offer a terse response. 1.14. What is the ratio of the Revenue generated (in %) in Iceland in 2005 to that in 2012?
Keep it short and to the point. 0.32. What is the ratio of the Revenue generated (in %) in Moldova in 2005 to that in 2012?
Offer a very short reply. 1.65. What is the ratio of the Revenue generated (in %) in Paraguay in 2005 to that in 2012?
Your answer should be compact. 5.37. What is the ratio of the Revenue generated (in %) of East Asia (all income levels) in 2006 to that in 2007?
Offer a terse response. 1.52. What is the ratio of the Revenue generated (in %) of Iceland in 2006 to that in 2007?
Your answer should be compact. 0.8. What is the ratio of the Revenue generated (in %) in Moldova in 2006 to that in 2007?
Give a very brief answer. 0.88. What is the ratio of the Revenue generated (in %) in Paraguay in 2006 to that in 2007?
Your answer should be very brief. 1.15. What is the ratio of the Revenue generated (in %) in East Asia (all income levels) in 2006 to that in 2008?
Ensure brevity in your answer.  1.28. What is the ratio of the Revenue generated (in %) in Iceland in 2006 to that in 2008?
Provide a succinct answer. 0.57. What is the ratio of the Revenue generated (in %) in Moldova in 2006 to that in 2008?
Your answer should be very brief. 0.88. What is the ratio of the Revenue generated (in %) in Paraguay in 2006 to that in 2008?
Keep it short and to the point. 1.57. What is the ratio of the Revenue generated (in %) in East Asia (all income levels) in 2006 to that in 2009?
Make the answer very short. 1.49. What is the ratio of the Revenue generated (in %) of Iceland in 2006 to that in 2009?
Your answer should be very brief. 0.24. What is the ratio of the Revenue generated (in %) in Moldova in 2006 to that in 2009?
Provide a succinct answer. 0.7. What is the ratio of the Revenue generated (in %) in Paraguay in 2006 to that in 2009?
Keep it short and to the point. 1.75. What is the ratio of the Revenue generated (in %) of East Asia (all income levels) in 2006 to that in 2010?
Ensure brevity in your answer.  1.34. What is the ratio of the Revenue generated (in %) of Iceland in 2006 to that in 2010?
Provide a succinct answer. 0.29. What is the ratio of the Revenue generated (in %) in Moldova in 2006 to that in 2010?
Offer a very short reply. 1.26. What is the ratio of the Revenue generated (in %) in Paraguay in 2006 to that in 2010?
Your answer should be very brief. 2.57. What is the ratio of the Revenue generated (in %) in East Asia (all income levels) in 2006 to that in 2011?
Your answer should be very brief. 1.18. What is the ratio of the Revenue generated (in %) of Iceland in 2006 to that in 2011?
Make the answer very short. 0.32. What is the ratio of the Revenue generated (in %) in Moldova in 2006 to that in 2011?
Make the answer very short. 1.13. What is the ratio of the Revenue generated (in %) in Paraguay in 2006 to that in 2011?
Provide a succinct answer. 3.68. What is the ratio of the Revenue generated (in %) in East Asia (all income levels) in 2006 to that in 2012?
Ensure brevity in your answer.  1.11. What is the ratio of the Revenue generated (in %) of Iceland in 2006 to that in 2012?
Ensure brevity in your answer.  0.31. What is the ratio of the Revenue generated (in %) in Moldova in 2006 to that in 2012?
Make the answer very short. 1.22. What is the ratio of the Revenue generated (in %) in Paraguay in 2006 to that in 2012?
Your answer should be compact. 4.45. What is the ratio of the Revenue generated (in %) of East Asia (all income levels) in 2007 to that in 2008?
Give a very brief answer. 0.84. What is the ratio of the Revenue generated (in %) of Iceland in 2007 to that in 2008?
Provide a short and direct response. 0.71. What is the ratio of the Revenue generated (in %) in Paraguay in 2007 to that in 2008?
Keep it short and to the point. 1.37. What is the ratio of the Revenue generated (in %) in East Asia (all income levels) in 2007 to that in 2009?
Offer a terse response. 0.98. What is the ratio of the Revenue generated (in %) in Iceland in 2007 to that in 2009?
Give a very brief answer. 0.3. What is the ratio of the Revenue generated (in %) in Moldova in 2007 to that in 2009?
Provide a short and direct response. 0.79. What is the ratio of the Revenue generated (in %) of Paraguay in 2007 to that in 2009?
Offer a very short reply. 1.53. What is the ratio of the Revenue generated (in %) of East Asia (all income levels) in 2007 to that in 2010?
Make the answer very short. 0.88. What is the ratio of the Revenue generated (in %) in Iceland in 2007 to that in 2010?
Your answer should be very brief. 0.37. What is the ratio of the Revenue generated (in %) in Moldova in 2007 to that in 2010?
Your answer should be very brief. 1.43. What is the ratio of the Revenue generated (in %) of Paraguay in 2007 to that in 2010?
Your response must be concise. 2.24. What is the ratio of the Revenue generated (in %) in East Asia (all income levels) in 2007 to that in 2011?
Your response must be concise. 0.77. What is the ratio of the Revenue generated (in %) of Iceland in 2007 to that in 2011?
Your response must be concise. 0.4. What is the ratio of the Revenue generated (in %) of Moldova in 2007 to that in 2011?
Give a very brief answer. 1.28. What is the ratio of the Revenue generated (in %) in Paraguay in 2007 to that in 2011?
Your response must be concise. 3.21. What is the ratio of the Revenue generated (in %) in East Asia (all income levels) in 2007 to that in 2012?
Provide a short and direct response. 0.73. What is the ratio of the Revenue generated (in %) in Iceland in 2007 to that in 2012?
Provide a short and direct response. 0.38. What is the ratio of the Revenue generated (in %) of Moldova in 2007 to that in 2012?
Your answer should be very brief. 1.38. What is the ratio of the Revenue generated (in %) in Paraguay in 2007 to that in 2012?
Offer a very short reply. 3.88. What is the ratio of the Revenue generated (in %) in East Asia (all income levels) in 2008 to that in 2009?
Ensure brevity in your answer.  1.16. What is the ratio of the Revenue generated (in %) of Iceland in 2008 to that in 2009?
Ensure brevity in your answer.  0.42. What is the ratio of the Revenue generated (in %) in Moldova in 2008 to that in 2009?
Offer a very short reply. 0.8. What is the ratio of the Revenue generated (in %) of Paraguay in 2008 to that in 2009?
Ensure brevity in your answer.  1.11. What is the ratio of the Revenue generated (in %) of East Asia (all income levels) in 2008 to that in 2010?
Provide a succinct answer. 1.04. What is the ratio of the Revenue generated (in %) of Iceland in 2008 to that in 2010?
Make the answer very short. 0.52. What is the ratio of the Revenue generated (in %) of Moldova in 2008 to that in 2010?
Give a very brief answer. 1.43. What is the ratio of the Revenue generated (in %) of Paraguay in 2008 to that in 2010?
Keep it short and to the point. 1.63. What is the ratio of the Revenue generated (in %) of East Asia (all income levels) in 2008 to that in 2011?
Provide a short and direct response. 0.92. What is the ratio of the Revenue generated (in %) of Iceland in 2008 to that in 2011?
Keep it short and to the point. 0.56. What is the ratio of the Revenue generated (in %) in Moldova in 2008 to that in 2011?
Provide a short and direct response. 1.29. What is the ratio of the Revenue generated (in %) of Paraguay in 2008 to that in 2011?
Make the answer very short. 2.34. What is the ratio of the Revenue generated (in %) of East Asia (all income levels) in 2008 to that in 2012?
Your answer should be very brief. 0.86. What is the ratio of the Revenue generated (in %) of Iceland in 2008 to that in 2012?
Your answer should be very brief. 0.54. What is the ratio of the Revenue generated (in %) in Moldova in 2008 to that in 2012?
Ensure brevity in your answer.  1.39. What is the ratio of the Revenue generated (in %) in Paraguay in 2008 to that in 2012?
Offer a very short reply. 2.83. What is the ratio of the Revenue generated (in %) in East Asia (all income levels) in 2009 to that in 2010?
Offer a very short reply. 0.9. What is the ratio of the Revenue generated (in %) in Iceland in 2009 to that in 2010?
Ensure brevity in your answer.  1.24. What is the ratio of the Revenue generated (in %) of Moldova in 2009 to that in 2010?
Your answer should be very brief. 1.8. What is the ratio of the Revenue generated (in %) in Paraguay in 2009 to that in 2010?
Keep it short and to the point. 1.47. What is the ratio of the Revenue generated (in %) of East Asia (all income levels) in 2009 to that in 2011?
Offer a terse response. 0.79. What is the ratio of the Revenue generated (in %) in Iceland in 2009 to that in 2011?
Provide a succinct answer. 1.35. What is the ratio of the Revenue generated (in %) in Moldova in 2009 to that in 2011?
Your answer should be very brief. 1.62. What is the ratio of the Revenue generated (in %) of Paraguay in 2009 to that in 2011?
Give a very brief answer. 2.11. What is the ratio of the Revenue generated (in %) of East Asia (all income levels) in 2009 to that in 2012?
Ensure brevity in your answer.  0.74. What is the ratio of the Revenue generated (in %) in Iceland in 2009 to that in 2012?
Keep it short and to the point. 1.29. What is the ratio of the Revenue generated (in %) in Moldova in 2009 to that in 2012?
Provide a succinct answer. 1.74. What is the ratio of the Revenue generated (in %) of Paraguay in 2009 to that in 2012?
Your answer should be very brief. 2.55. What is the ratio of the Revenue generated (in %) of East Asia (all income levels) in 2010 to that in 2011?
Make the answer very short. 0.88. What is the ratio of the Revenue generated (in %) of Iceland in 2010 to that in 2011?
Keep it short and to the point. 1.08. What is the ratio of the Revenue generated (in %) in Moldova in 2010 to that in 2011?
Make the answer very short. 0.9. What is the ratio of the Revenue generated (in %) in Paraguay in 2010 to that in 2011?
Provide a short and direct response. 1.43. What is the ratio of the Revenue generated (in %) in East Asia (all income levels) in 2010 to that in 2012?
Offer a terse response. 0.83. What is the ratio of the Revenue generated (in %) in Iceland in 2010 to that in 2012?
Offer a terse response. 1.04. What is the ratio of the Revenue generated (in %) in Moldova in 2010 to that in 2012?
Offer a very short reply. 0.97. What is the ratio of the Revenue generated (in %) of Paraguay in 2010 to that in 2012?
Your answer should be very brief. 1.73. What is the ratio of the Revenue generated (in %) in East Asia (all income levels) in 2011 to that in 2012?
Your answer should be very brief. 0.94. What is the ratio of the Revenue generated (in %) of Iceland in 2011 to that in 2012?
Provide a short and direct response. 0.96. What is the ratio of the Revenue generated (in %) of Moldova in 2011 to that in 2012?
Offer a very short reply. 1.08. What is the ratio of the Revenue generated (in %) of Paraguay in 2011 to that in 2012?
Ensure brevity in your answer.  1.21. What is the difference between the highest and the second highest Revenue generated (in %) of East Asia (all income levels)?
Your answer should be compact. 0.15. What is the difference between the highest and the second highest Revenue generated (in %) in Iceland?
Provide a succinct answer. 4.05. What is the difference between the highest and the second highest Revenue generated (in %) of Moldova?
Your answer should be compact. 0.22. What is the difference between the highest and the second highest Revenue generated (in %) of Paraguay?
Your response must be concise. 0.96. What is the difference between the highest and the lowest Revenue generated (in %) in East Asia (all income levels)?
Your answer should be compact. 1.93. What is the difference between the highest and the lowest Revenue generated (in %) of Iceland?
Make the answer very short. 15.76. What is the difference between the highest and the lowest Revenue generated (in %) in Moldova?
Offer a very short reply. 1.78. What is the difference between the highest and the lowest Revenue generated (in %) of Paraguay?
Your response must be concise. 4.54. 